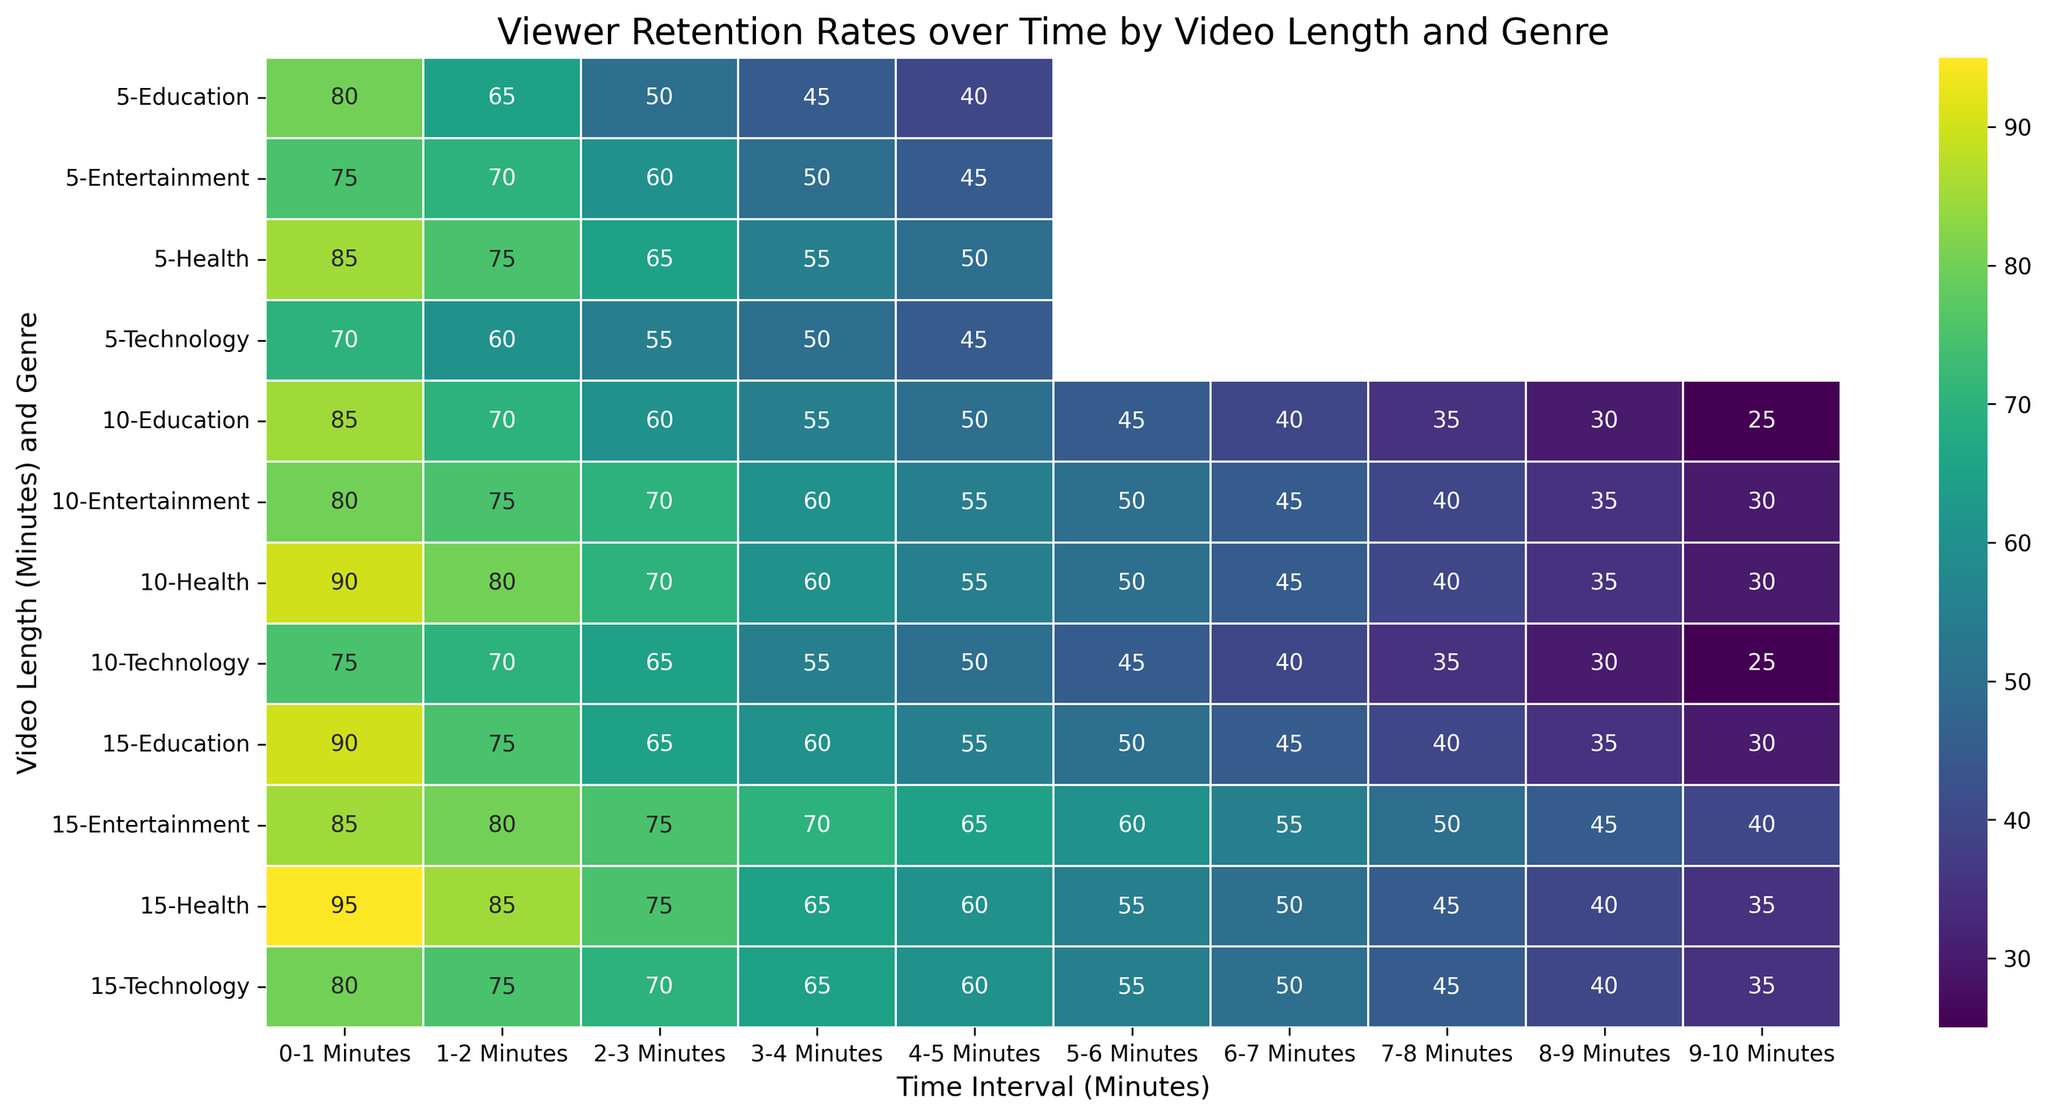How does the viewer retention rate of a 10-minute Technology video compare to a 10-minute Entertainment video at the 2-3 minute mark? Look at the retention rates for both 10-minute Technology (65%) and 10-minute Entertainment (70%) videos in the 2-3 minute interval. The Entertainment video has a higher retention rate.
Answer: Entertainment video is higher What is the average viewer retention rate for a 15-minute Health video over the first 4 minutes? Identify the retention rates of the 15-minute Health video for the first 4 minutes (95%, 85%, 75%, 65%). Sum these rates: 95 + 85 + 75 + 65 = 320, then divide by 4 to get the average: 320 / 4 = 80.
Answer: 80 Which video genre has the highest retention rate at the 3-4 minute mark for 15-minute videos? Compare the 3-4 minute retention rates of 15-minute videos across genres: Education (60%), Entertainment (70%), Technology (65%), Health (65%). Entertainment has the highest rate.
Answer: Entertainment Does the viewer retention rate decrease more rapidly over time in 5-minute Education videos or 5-minute Health videos? Compare the retention rates from 0-1 to 4-5 minutes for 5-minute Education (80%, 65%, 50%, 45%, 40%) and Health videos (85%, 75%, 65%, 55%, 50%). The Education video retention rates drop by 40 points, while Health videos drop by 35 points.
Answer: Education videos What is the retention rate difference between viewers of 10-minute Entertainment and 10-minute Educational videos in the 5-6 minute mark? Identify the retention rates of 10-minute Entertainment (50%) and 10-minute Educational (45%) videos in the 5-6 minute interval. Subtract the Educational retention rate from the Entertainment retention rate: 50 - 45 = 5.
Answer: 5 For 15-minute videos, which genre shows the most uniform decrease in viewer retention rates across all time intervals? Compare the retention rates decreases across intervals for 15-minute videos in each genre: Education (90% to 30%), Entertainment (85% to 40%), Technology (80% to 35%), Health (95% to 35%). The smallest difference between the highest and lowest values indicates uniformity: Entertainment decreases by 45 points, the least among them.
Answer: Entertainment At the 4-5 minute mark, how does the retention rate for 10-minute Technology videos compare to that of 15-minute Education videos? Find the retention rates at 4-5 minutes for 10-minute Technology (50%) and 15-minute Education (55%) videos. The Education video's rate is higher by 5 points.
Answer: Education videos higher Which genre has the least retention rate at 9-10 minutes for 15-minute videos? Compare the retention rates at 9-10 minutes for 15-minute videos across genres: Education (30%), Entertainment (40%), Technology (35%), Health (35%). Education has the lowest rate.
Answer: Education 